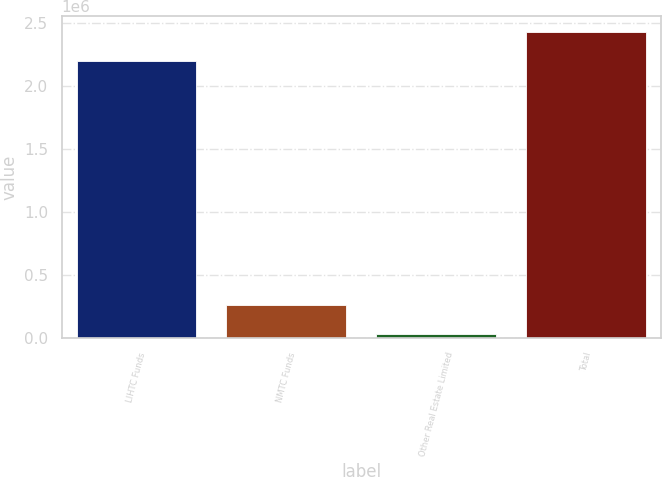Convert chart. <chart><loc_0><loc_0><loc_500><loc_500><bar_chart><fcel>LIHTC Funds<fcel>NMTC Funds<fcel>Other Real Estate Limited<fcel>Total<nl><fcel>2.19805e+06<fcel>264980<fcel>31107<fcel>2.43192e+06<nl></chart> 